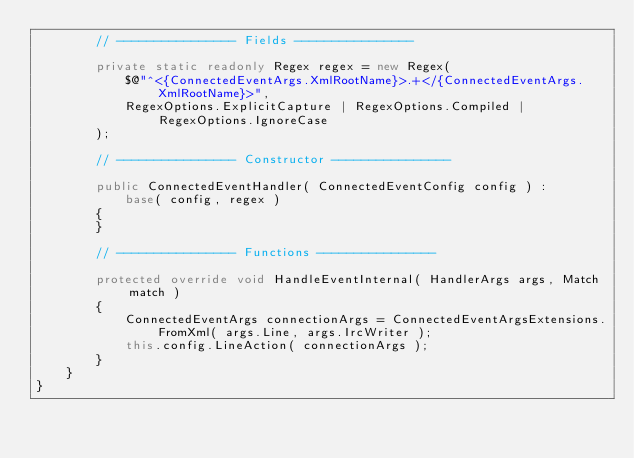<code> <loc_0><loc_0><loc_500><loc_500><_C#_>        // ---------------- Fields ----------------

        private static readonly Regex regex = new Regex(
            $@"^<{ConnectedEventArgs.XmlRootName}>.+</{ConnectedEventArgs.XmlRootName}>",
            RegexOptions.ExplicitCapture | RegexOptions.Compiled | RegexOptions.IgnoreCase
        );

        // ---------------- Constructor ----------------

        public ConnectedEventHandler( ConnectedEventConfig config ) :
            base( config, regex )
        {
        }

        // ---------------- Functions ----------------

        protected override void HandleEventInternal( HandlerArgs args, Match match )
        {
            ConnectedEventArgs connectionArgs = ConnectedEventArgsExtensions.FromXml( args.Line, args.IrcWriter );
            this.config.LineAction( connectionArgs );
        }
    }
}
</code> 